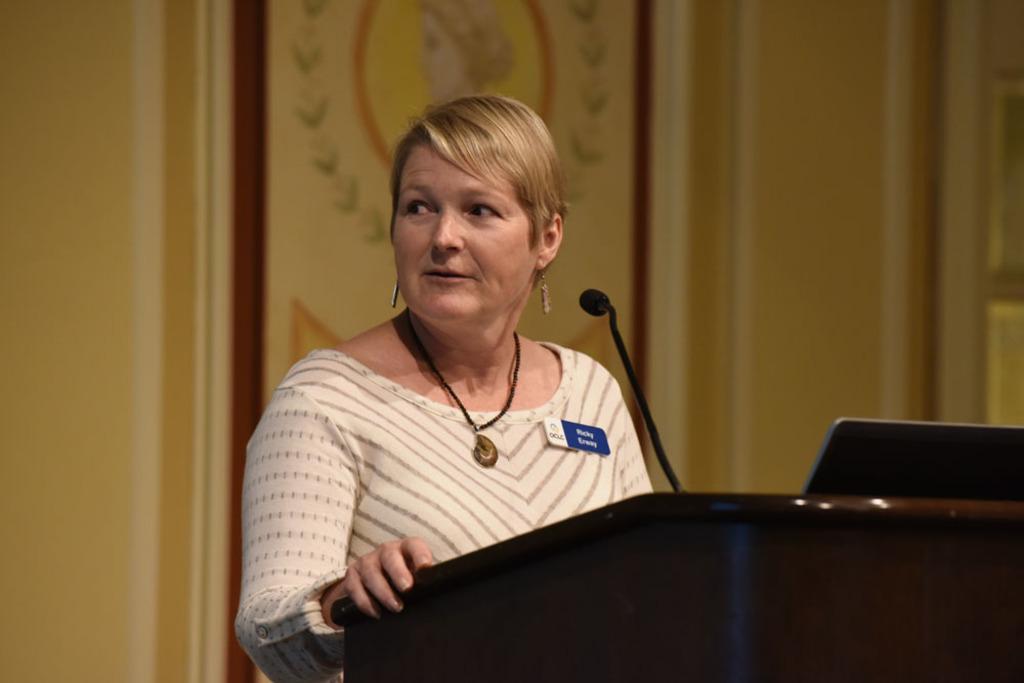Could you give a brief overview of what you see in this image? In this image I can see there is a woman standing behind the podium and there is a microphone, laptop in front of her. In the background there is a wall. 